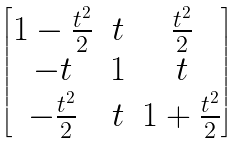Convert formula to latex. <formula><loc_0><loc_0><loc_500><loc_500>\begin{bmatrix} 1 - \frac { t ^ { 2 } } { 2 } & t & \frac { t ^ { 2 } } { 2 } \\ - t & 1 & t \\ - \frac { t ^ { 2 } } { 2 } & t & 1 + \frac { t ^ { 2 } } { 2 } \end{bmatrix}</formula> 